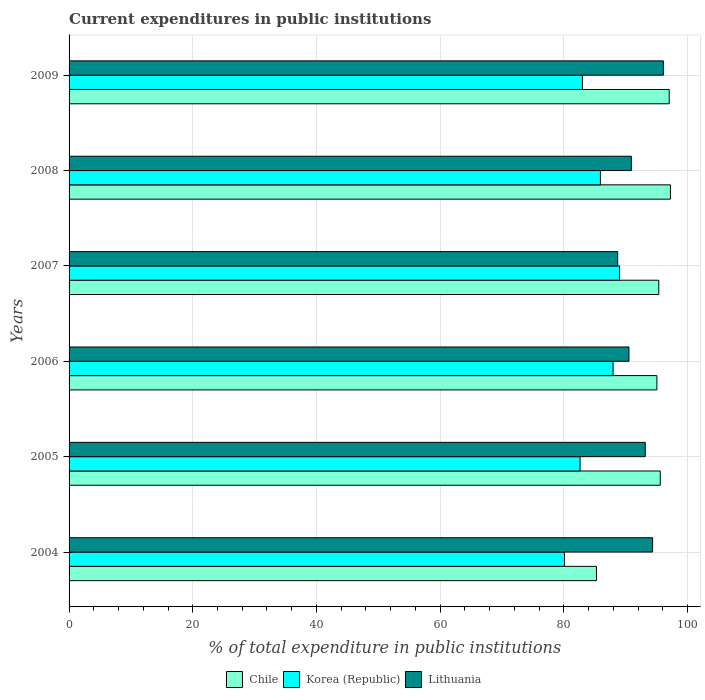How many different coloured bars are there?
Ensure brevity in your answer.  3. Are the number of bars per tick equal to the number of legend labels?
Your answer should be very brief. Yes. How many bars are there on the 2nd tick from the bottom?
Your response must be concise. 3. In how many cases, is the number of bars for a given year not equal to the number of legend labels?
Your answer should be compact. 0. What is the current expenditures in public institutions in Korea (Republic) in 2008?
Keep it short and to the point. 85.91. Across all years, what is the maximum current expenditures in public institutions in Chile?
Offer a very short reply. 97.23. Across all years, what is the minimum current expenditures in public institutions in Korea (Republic)?
Provide a short and direct response. 80.09. In which year was the current expenditures in public institutions in Korea (Republic) maximum?
Provide a succinct answer. 2007. In which year was the current expenditures in public institutions in Chile minimum?
Make the answer very short. 2004. What is the total current expenditures in public institutions in Lithuania in the graph?
Your response must be concise. 553.73. What is the difference between the current expenditures in public institutions in Lithuania in 2006 and that in 2007?
Ensure brevity in your answer.  1.83. What is the difference between the current expenditures in public institutions in Chile in 2009 and the current expenditures in public institutions in Korea (Republic) in 2008?
Your response must be concise. 11.12. What is the average current expenditures in public institutions in Chile per year?
Make the answer very short. 94.25. In the year 2008, what is the difference between the current expenditures in public institutions in Korea (Republic) and current expenditures in public institutions in Lithuania?
Provide a short and direct response. -5. In how many years, is the current expenditures in public institutions in Chile greater than 52 %?
Your response must be concise. 6. What is the ratio of the current expenditures in public institutions in Chile in 2005 to that in 2006?
Your answer should be compact. 1.01. What is the difference between the highest and the second highest current expenditures in public institutions in Chile?
Offer a very short reply. 0.2. What is the difference between the highest and the lowest current expenditures in public institutions in Lithuania?
Offer a very short reply. 7.39. Is the sum of the current expenditures in public institutions in Chile in 2006 and 2008 greater than the maximum current expenditures in public institutions in Lithuania across all years?
Make the answer very short. Yes. What does the 2nd bar from the top in 2007 represents?
Provide a short and direct response. Korea (Republic). What does the 3rd bar from the bottom in 2008 represents?
Offer a terse response. Lithuania. Are all the bars in the graph horizontal?
Offer a very short reply. Yes. How many years are there in the graph?
Make the answer very short. 6. Does the graph contain any zero values?
Keep it short and to the point. No. Where does the legend appear in the graph?
Offer a terse response. Bottom center. What is the title of the graph?
Offer a terse response. Current expenditures in public institutions. Does "Guatemala" appear as one of the legend labels in the graph?
Your response must be concise. No. What is the label or title of the X-axis?
Offer a very short reply. % of total expenditure in public institutions. What is the label or title of the Y-axis?
Your answer should be compact. Years. What is the % of total expenditure in public institutions of Chile in 2004?
Give a very brief answer. 85.27. What is the % of total expenditure in public institutions of Korea (Republic) in 2004?
Ensure brevity in your answer.  80.09. What is the % of total expenditure in public institutions of Lithuania in 2004?
Give a very brief answer. 94.35. What is the % of total expenditure in public institutions in Chile in 2005?
Offer a terse response. 95.59. What is the % of total expenditure in public institutions in Korea (Republic) in 2005?
Make the answer very short. 82.62. What is the % of total expenditure in public institutions in Lithuania in 2005?
Keep it short and to the point. 93.16. What is the % of total expenditure in public institutions in Chile in 2006?
Your answer should be compact. 95.04. What is the % of total expenditure in public institutions of Korea (Republic) in 2006?
Your answer should be very brief. 87.96. What is the % of total expenditure in public institutions in Lithuania in 2006?
Your answer should be compact. 90.53. What is the % of total expenditure in public institutions in Chile in 2007?
Provide a short and direct response. 95.35. What is the % of total expenditure in public institutions in Korea (Republic) in 2007?
Give a very brief answer. 88.99. What is the % of total expenditure in public institutions of Lithuania in 2007?
Ensure brevity in your answer.  88.7. What is the % of total expenditure in public institutions of Chile in 2008?
Offer a terse response. 97.23. What is the % of total expenditure in public institutions in Korea (Republic) in 2008?
Provide a succinct answer. 85.91. What is the % of total expenditure in public institutions in Lithuania in 2008?
Your answer should be very brief. 90.91. What is the % of total expenditure in public institutions of Chile in 2009?
Your answer should be very brief. 97.03. What is the % of total expenditure in public institutions of Korea (Republic) in 2009?
Offer a terse response. 83. What is the % of total expenditure in public institutions in Lithuania in 2009?
Keep it short and to the point. 96.09. Across all years, what is the maximum % of total expenditure in public institutions in Chile?
Offer a very short reply. 97.23. Across all years, what is the maximum % of total expenditure in public institutions of Korea (Republic)?
Give a very brief answer. 88.99. Across all years, what is the maximum % of total expenditure in public institutions of Lithuania?
Give a very brief answer. 96.09. Across all years, what is the minimum % of total expenditure in public institutions in Chile?
Give a very brief answer. 85.27. Across all years, what is the minimum % of total expenditure in public institutions in Korea (Republic)?
Offer a terse response. 80.09. Across all years, what is the minimum % of total expenditure in public institutions in Lithuania?
Keep it short and to the point. 88.7. What is the total % of total expenditure in public institutions of Chile in the graph?
Your response must be concise. 565.51. What is the total % of total expenditure in public institutions in Korea (Republic) in the graph?
Provide a succinct answer. 508.58. What is the total % of total expenditure in public institutions of Lithuania in the graph?
Your answer should be compact. 553.73. What is the difference between the % of total expenditure in public institutions in Chile in 2004 and that in 2005?
Offer a terse response. -10.32. What is the difference between the % of total expenditure in public institutions in Korea (Republic) in 2004 and that in 2005?
Your answer should be very brief. -2.53. What is the difference between the % of total expenditure in public institutions in Lithuania in 2004 and that in 2005?
Your response must be concise. 1.19. What is the difference between the % of total expenditure in public institutions in Chile in 2004 and that in 2006?
Offer a terse response. -9.77. What is the difference between the % of total expenditure in public institutions in Korea (Republic) in 2004 and that in 2006?
Your response must be concise. -7.87. What is the difference between the % of total expenditure in public institutions of Lithuania in 2004 and that in 2006?
Your answer should be very brief. 3.82. What is the difference between the % of total expenditure in public institutions of Chile in 2004 and that in 2007?
Ensure brevity in your answer.  -10.08. What is the difference between the % of total expenditure in public institutions of Korea (Republic) in 2004 and that in 2007?
Your answer should be compact. -8.9. What is the difference between the % of total expenditure in public institutions of Lithuania in 2004 and that in 2007?
Provide a succinct answer. 5.65. What is the difference between the % of total expenditure in public institutions in Chile in 2004 and that in 2008?
Provide a short and direct response. -11.96. What is the difference between the % of total expenditure in public institutions in Korea (Republic) in 2004 and that in 2008?
Your answer should be very brief. -5.82. What is the difference between the % of total expenditure in public institutions in Lithuania in 2004 and that in 2008?
Your answer should be very brief. 3.44. What is the difference between the % of total expenditure in public institutions of Chile in 2004 and that in 2009?
Provide a succinct answer. -11.76. What is the difference between the % of total expenditure in public institutions of Korea (Republic) in 2004 and that in 2009?
Offer a very short reply. -2.91. What is the difference between the % of total expenditure in public institutions in Lithuania in 2004 and that in 2009?
Your response must be concise. -1.74. What is the difference between the % of total expenditure in public institutions in Chile in 2005 and that in 2006?
Provide a short and direct response. 0.55. What is the difference between the % of total expenditure in public institutions in Korea (Republic) in 2005 and that in 2006?
Your answer should be compact. -5.34. What is the difference between the % of total expenditure in public institutions in Lithuania in 2005 and that in 2006?
Provide a succinct answer. 2.63. What is the difference between the % of total expenditure in public institutions in Chile in 2005 and that in 2007?
Your answer should be very brief. 0.24. What is the difference between the % of total expenditure in public institutions of Korea (Republic) in 2005 and that in 2007?
Give a very brief answer. -6.37. What is the difference between the % of total expenditure in public institutions of Lithuania in 2005 and that in 2007?
Give a very brief answer. 4.46. What is the difference between the % of total expenditure in public institutions of Chile in 2005 and that in 2008?
Offer a very short reply. -1.64. What is the difference between the % of total expenditure in public institutions in Korea (Republic) in 2005 and that in 2008?
Keep it short and to the point. -3.29. What is the difference between the % of total expenditure in public institutions of Lithuania in 2005 and that in 2008?
Ensure brevity in your answer.  2.25. What is the difference between the % of total expenditure in public institutions in Chile in 2005 and that in 2009?
Offer a terse response. -1.44. What is the difference between the % of total expenditure in public institutions in Korea (Republic) in 2005 and that in 2009?
Offer a terse response. -0.38. What is the difference between the % of total expenditure in public institutions of Lithuania in 2005 and that in 2009?
Give a very brief answer. -2.93. What is the difference between the % of total expenditure in public institutions of Chile in 2006 and that in 2007?
Offer a terse response. -0.31. What is the difference between the % of total expenditure in public institutions in Korea (Republic) in 2006 and that in 2007?
Make the answer very short. -1.03. What is the difference between the % of total expenditure in public institutions of Lithuania in 2006 and that in 2007?
Your answer should be very brief. 1.83. What is the difference between the % of total expenditure in public institutions of Chile in 2006 and that in 2008?
Provide a short and direct response. -2.19. What is the difference between the % of total expenditure in public institutions in Korea (Republic) in 2006 and that in 2008?
Offer a very short reply. 2.05. What is the difference between the % of total expenditure in public institutions in Lithuania in 2006 and that in 2008?
Make the answer very short. -0.38. What is the difference between the % of total expenditure in public institutions of Chile in 2006 and that in 2009?
Make the answer very short. -1.99. What is the difference between the % of total expenditure in public institutions in Korea (Republic) in 2006 and that in 2009?
Make the answer very short. 4.96. What is the difference between the % of total expenditure in public institutions of Lithuania in 2006 and that in 2009?
Make the answer very short. -5.56. What is the difference between the % of total expenditure in public institutions in Chile in 2007 and that in 2008?
Provide a succinct answer. -1.88. What is the difference between the % of total expenditure in public institutions in Korea (Republic) in 2007 and that in 2008?
Offer a terse response. 3.08. What is the difference between the % of total expenditure in public institutions in Lithuania in 2007 and that in 2008?
Your answer should be compact. -2.21. What is the difference between the % of total expenditure in public institutions in Chile in 2007 and that in 2009?
Offer a terse response. -1.68. What is the difference between the % of total expenditure in public institutions in Korea (Republic) in 2007 and that in 2009?
Your answer should be very brief. 5.99. What is the difference between the % of total expenditure in public institutions of Lithuania in 2007 and that in 2009?
Offer a terse response. -7.39. What is the difference between the % of total expenditure in public institutions in Chile in 2008 and that in 2009?
Provide a short and direct response. 0.2. What is the difference between the % of total expenditure in public institutions of Korea (Republic) in 2008 and that in 2009?
Your response must be concise. 2.91. What is the difference between the % of total expenditure in public institutions of Lithuania in 2008 and that in 2009?
Provide a succinct answer. -5.18. What is the difference between the % of total expenditure in public institutions of Chile in 2004 and the % of total expenditure in public institutions of Korea (Republic) in 2005?
Give a very brief answer. 2.65. What is the difference between the % of total expenditure in public institutions of Chile in 2004 and the % of total expenditure in public institutions of Lithuania in 2005?
Offer a very short reply. -7.88. What is the difference between the % of total expenditure in public institutions in Korea (Republic) in 2004 and the % of total expenditure in public institutions in Lithuania in 2005?
Offer a terse response. -13.06. What is the difference between the % of total expenditure in public institutions of Chile in 2004 and the % of total expenditure in public institutions of Korea (Republic) in 2006?
Keep it short and to the point. -2.69. What is the difference between the % of total expenditure in public institutions in Chile in 2004 and the % of total expenditure in public institutions in Lithuania in 2006?
Provide a succinct answer. -5.25. What is the difference between the % of total expenditure in public institutions of Korea (Republic) in 2004 and the % of total expenditure in public institutions of Lithuania in 2006?
Offer a terse response. -10.43. What is the difference between the % of total expenditure in public institutions in Chile in 2004 and the % of total expenditure in public institutions in Korea (Republic) in 2007?
Make the answer very short. -3.72. What is the difference between the % of total expenditure in public institutions in Chile in 2004 and the % of total expenditure in public institutions in Lithuania in 2007?
Your answer should be very brief. -3.43. What is the difference between the % of total expenditure in public institutions of Korea (Republic) in 2004 and the % of total expenditure in public institutions of Lithuania in 2007?
Make the answer very short. -8.61. What is the difference between the % of total expenditure in public institutions of Chile in 2004 and the % of total expenditure in public institutions of Korea (Republic) in 2008?
Keep it short and to the point. -0.64. What is the difference between the % of total expenditure in public institutions in Chile in 2004 and the % of total expenditure in public institutions in Lithuania in 2008?
Your response must be concise. -5.64. What is the difference between the % of total expenditure in public institutions of Korea (Republic) in 2004 and the % of total expenditure in public institutions of Lithuania in 2008?
Provide a short and direct response. -10.82. What is the difference between the % of total expenditure in public institutions of Chile in 2004 and the % of total expenditure in public institutions of Korea (Republic) in 2009?
Provide a short and direct response. 2.27. What is the difference between the % of total expenditure in public institutions of Chile in 2004 and the % of total expenditure in public institutions of Lithuania in 2009?
Your answer should be compact. -10.82. What is the difference between the % of total expenditure in public institutions in Korea (Republic) in 2004 and the % of total expenditure in public institutions in Lithuania in 2009?
Your answer should be compact. -16. What is the difference between the % of total expenditure in public institutions in Chile in 2005 and the % of total expenditure in public institutions in Korea (Republic) in 2006?
Make the answer very short. 7.63. What is the difference between the % of total expenditure in public institutions of Chile in 2005 and the % of total expenditure in public institutions of Lithuania in 2006?
Offer a very short reply. 5.06. What is the difference between the % of total expenditure in public institutions of Korea (Republic) in 2005 and the % of total expenditure in public institutions of Lithuania in 2006?
Provide a succinct answer. -7.91. What is the difference between the % of total expenditure in public institutions in Chile in 2005 and the % of total expenditure in public institutions in Korea (Republic) in 2007?
Make the answer very short. 6.6. What is the difference between the % of total expenditure in public institutions of Chile in 2005 and the % of total expenditure in public institutions of Lithuania in 2007?
Provide a succinct answer. 6.89. What is the difference between the % of total expenditure in public institutions of Korea (Republic) in 2005 and the % of total expenditure in public institutions of Lithuania in 2007?
Make the answer very short. -6.08. What is the difference between the % of total expenditure in public institutions of Chile in 2005 and the % of total expenditure in public institutions of Korea (Republic) in 2008?
Your answer should be compact. 9.68. What is the difference between the % of total expenditure in public institutions of Chile in 2005 and the % of total expenditure in public institutions of Lithuania in 2008?
Make the answer very short. 4.68. What is the difference between the % of total expenditure in public institutions of Korea (Republic) in 2005 and the % of total expenditure in public institutions of Lithuania in 2008?
Keep it short and to the point. -8.29. What is the difference between the % of total expenditure in public institutions of Chile in 2005 and the % of total expenditure in public institutions of Korea (Republic) in 2009?
Offer a terse response. 12.59. What is the difference between the % of total expenditure in public institutions of Chile in 2005 and the % of total expenditure in public institutions of Lithuania in 2009?
Keep it short and to the point. -0.5. What is the difference between the % of total expenditure in public institutions of Korea (Republic) in 2005 and the % of total expenditure in public institutions of Lithuania in 2009?
Your response must be concise. -13.47. What is the difference between the % of total expenditure in public institutions in Chile in 2006 and the % of total expenditure in public institutions in Korea (Republic) in 2007?
Ensure brevity in your answer.  6.05. What is the difference between the % of total expenditure in public institutions in Chile in 2006 and the % of total expenditure in public institutions in Lithuania in 2007?
Provide a short and direct response. 6.34. What is the difference between the % of total expenditure in public institutions of Korea (Republic) in 2006 and the % of total expenditure in public institutions of Lithuania in 2007?
Provide a succinct answer. -0.74. What is the difference between the % of total expenditure in public institutions of Chile in 2006 and the % of total expenditure in public institutions of Korea (Republic) in 2008?
Your answer should be very brief. 9.13. What is the difference between the % of total expenditure in public institutions of Chile in 2006 and the % of total expenditure in public institutions of Lithuania in 2008?
Provide a short and direct response. 4.13. What is the difference between the % of total expenditure in public institutions of Korea (Republic) in 2006 and the % of total expenditure in public institutions of Lithuania in 2008?
Make the answer very short. -2.95. What is the difference between the % of total expenditure in public institutions of Chile in 2006 and the % of total expenditure in public institutions of Korea (Republic) in 2009?
Your answer should be very brief. 12.04. What is the difference between the % of total expenditure in public institutions of Chile in 2006 and the % of total expenditure in public institutions of Lithuania in 2009?
Give a very brief answer. -1.05. What is the difference between the % of total expenditure in public institutions of Korea (Republic) in 2006 and the % of total expenditure in public institutions of Lithuania in 2009?
Ensure brevity in your answer.  -8.13. What is the difference between the % of total expenditure in public institutions in Chile in 2007 and the % of total expenditure in public institutions in Korea (Republic) in 2008?
Offer a very short reply. 9.44. What is the difference between the % of total expenditure in public institutions of Chile in 2007 and the % of total expenditure in public institutions of Lithuania in 2008?
Ensure brevity in your answer.  4.44. What is the difference between the % of total expenditure in public institutions in Korea (Republic) in 2007 and the % of total expenditure in public institutions in Lithuania in 2008?
Ensure brevity in your answer.  -1.92. What is the difference between the % of total expenditure in public institutions in Chile in 2007 and the % of total expenditure in public institutions in Korea (Republic) in 2009?
Provide a succinct answer. 12.35. What is the difference between the % of total expenditure in public institutions of Chile in 2007 and the % of total expenditure in public institutions of Lithuania in 2009?
Offer a terse response. -0.74. What is the difference between the % of total expenditure in public institutions in Korea (Republic) in 2007 and the % of total expenditure in public institutions in Lithuania in 2009?
Ensure brevity in your answer.  -7.1. What is the difference between the % of total expenditure in public institutions of Chile in 2008 and the % of total expenditure in public institutions of Korea (Republic) in 2009?
Your response must be concise. 14.23. What is the difference between the % of total expenditure in public institutions in Chile in 2008 and the % of total expenditure in public institutions in Lithuania in 2009?
Your answer should be compact. 1.14. What is the difference between the % of total expenditure in public institutions of Korea (Republic) in 2008 and the % of total expenditure in public institutions of Lithuania in 2009?
Offer a terse response. -10.18. What is the average % of total expenditure in public institutions of Chile per year?
Offer a terse response. 94.25. What is the average % of total expenditure in public institutions of Korea (Republic) per year?
Give a very brief answer. 84.76. What is the average % of total expenditure in public institutions in Lithuania per year?
Your answer should be compact. 92.29. In the year 2004, what is the difference between the % of total expenditure in public institutions of Chile and % of total expenditure in public institutions of Korea (Republic)?
Provide a short and direct response. 5.18. In the year 2004, what is the difference between the % of total expenditure in public institutions in Chile and % of total expenditure in public institutions in Lithuania?
Provide a short and direct response. -9.08. In the year 2004, what is the difference between the % of total expenditure in public institutions of Korea (Republic) and % of total expenditure in public institutions of Lithuania?
Your answer should be very brief. -14.26. In the year 2005, what is the difference between the % of total expenditure in public institutions of Chile and % of total expenditure in public institutions of Korea (Republic)?
Make the answer very short. 12.97. In the year 2005, what is the difference between the % of total expenditure in public institutions of Chile and % of total expenditure in public institutions of Lithuania?
Provide a succinct answer. 2.43. In the year 2005, what is the difference between the % of total expenditure in public institutions of Korea (Republic) and % of total expenditure in public institutions of Lithuania?
Ensure brevity in your answer.  -10.53. In the year 2006, what is the difference between the % of total expenditure in public institutions in Chile and % of total expenditure in public institutions in Korea (Republic)?
Keep it short and to the point. 7.08. In the year 2006, what is the difference between the % of total expenditure in public institutions of Chile and % of total expenditure in public institutions of Lithuania?
Keep it short and to the point. 4.51. In the year 2006, what is the difference between the % of total expenditure in public institutions in Korea (Republic) and % of total expenditure in public institutions in Lithuania?
Offer a very short reply. -2.57. In the year 2007, what is the difference between the % of total expenditure in public institutions of Chile and % of total expenditure in public institutions of Korea (Republic)?
Give a very brief answer. 6.36. In the year 2007, what is the difference between the % of total expenditure in public institutions of Chile and % of total expenditure in public institutions of Lithuania?
Your response must be concise. 6.65. In the year 2007, what is the difference between the % of total expenditure in public institutions in Korea (Republic) and % of total expenditure in public institutions in Lithuania?
Your answer should be very brief. 0.29. In the year 2008, what is the difference between the % of total expenditure in public institutions in Chile and % of total expenditure in public institutions in Korea (Republic)?
Offer a terse response. 11.32. In the year 2008, what is the difference between the % of total expenditure in public institutions in Chile and % of total expenditure in public institutions in Lithuania?
Give a very brief answer. 6.32. In the year 2008, what is the difference between the % of total expenditure in public institutions in Korea (Republic) and % of total expenditure in public institutions in Lithuania?
Give a very brief answer. -5. In the year 2009, what is the difference between the % of total expenditure in public institutions of Chile and % of total expenditure in public institutions of Korea (Republic)?
Ensure brevity in your answer.  14.03. In the year 2009, what is the difference between the % of total expenditure in public institutions in Chile and % of total expenditure in public institutions in Lithuania?
Offer a very short reply. 0.94. In the year 2009, what is the difference between the % of total expenditure in public institutions of Korea (Republic) and % of total expenditure in public institutions of Lithuania?
Keep it short and to the point. -13.09. What is the ratio of the % of total expenditure in public institutions in Chile in 2004 to that in 2005?
Keep it short and to the point. 0.89. What is the ratio of the % of total expenditure in public institutions in Korea (Republic) in 2004 to that in 2005?
Give a very brief answer. 0.97. What is the ratio of the % of total expenditure in public institutions in Lithuania in 2004 to that in 2005?
Provide a short and direct response. 1.01. What is the ratio of the % of total expenditure in public institutions in Chile in 2004 to that in 2006?
Offer a terse response. 0.9. What is the ratio of the % of total expenditure in public institutions in Korea (Republic) in 2004 to that in 2006?
Your answer should be very brief. 0.91. What is the ratio of the % of total expenditure in public institutions of Lithuania in 2004 to that in 2006?
Provide a succinct answer. 1.04. What is the ratio of the % of total expenditure in public institutions in Chile in 2004 to that in 2007?
Give a very brief answer. 0.89. What is the ratio of the % of total expenditure in public institutions of Lithuania in 2004 to that in 2007?
Your answer should be compact. 1.06. What is the ratio of the % of total expenditure in public institutions in Chile in 2004 to that in 2008?
Your answer should be compact. 0.88. What is the ratio of the % of total expenditure in public institutions of Korea (Republic) in 2004 to that in 2008?
Your response must be concise. 0.93. What is the ratio of the % of total expenditure in public institutions in Lithuania in 2004 to that in 2008?
Your answer should be compact. 1.04. What is the ratio of the % of total expenditure in public institutions in Chile in 2004 to that in 2009?
Make the answer very short. 0.88. What is the ratio of the % of total expenditure in public institutions in Korea (Republic) in 2004 to that in 2009?
Offer a very short reply. 0.96. What is the ratio of the % of total expenditure in public institutions in Lithuania in 2004 to that in 2009?
Give a very brief answer. 0.98. What is the ratio of the % of total expenditure in public institutions of Korea (Republic) in 2005 to that in 2006?
Provide a succinct answer. 0.94. What is the ratio of the % of total expenditure in public institutions in Lithuania in 2005 to that in 2006?
Your response must be concise. 1.03. What is the ratio of the % of total expenditure in public institutions of Korea (Republic) in 2005 to that in 2007?
Provide a short and direct response. 0.93. What is the ratio of the % of total expenditure in public institutions in Lithuania in 2005 to that in 2007?
Your answer should be compact. 1.05. What is the ratio of the % of total expenditure in public institutions of Chile in 2005 to that in 2008?
Offer a terse response. 0.98. What is the ratio of the % of total expenditure in public institutions of Korea (Republic) in 2005 to that in 2008?
Offer a terse response. 0.96. What is the ratio of the % of total expenditure in public institutions in Lithuania in 2005 to that in 2008?
Ensure brevity in your answer.  1.02. What is the ratio of the % of total expenditure in public institutions of Chile in 2005 to that in 2009?
Your answer should be compact. 0.99. What is the ratio of the % of total expenditure in public institutions in Lithuania in 2005 to that in 2009?
Your answer should be compact. 0.97. What is the ratio of the % of total expenditure in public institutions of Chile in 2006 to that in 2007?
Offer a terse response. 1. What is the ratio of the % of total expenditure in public institutions in Korea (Republic) in 2006 to that in 2007?
Your answer should be compact. 0.99. What is the ratio of the % of total expenditure in public institutions in Lithuania in 2006 to that in 2007?
Offer a very short reply. 1.02. What is the ratio of the % of total expenditure in public institutions of Chile in 2006 to that in 2008?
Provide a succinct answer. 0.98. What is the ratio of the % of total expenditure in public institutions of Korea (Republic) in 2006 to that in 2008?
Your answer should be compact. 1.02. What is the ratio of the % of total expenditure in public institutions in Chile in 2006 to that in 2009?
Give a very brief answer. 0.98. What is the ratio of the % of total expenditure in public institutions in Korea (Republic) in 2006 to that in 2009?
Make the answer very short. 1.06. What is the ratio of the % of total expenditure in public institutions in Lithuania in 2006 to that in 2009?
Ensure brevity in your answer.  0.94. What is the ratio of the % of total expenditure in public institutions in Chile in 2007 to that in 2008?
Your answer should be compact. 0.98. What is the ratio of the % of total expenditure in public institutions in Korea (Republic) in 2007 to that in 2008?
Provide a succinct answer. 1.04. What is the ratio of the % of total expenditure in public institutions of Lithuania in 2007 to that in 2008?
Provide a succinct answer. 0.98. What is the ratio of the % of total expenditure in public institutions in Chile in 2007 to that in 2009?
Your answer should be very brief. 0.98. What is the ratio of the % of total expenditure in public institutions in Korea (Republic) in 2007 to that in 2009?
Your answer should be compact. 1.07. What is the ratio of the % of total expenditure in public institutions in Korea (Republic) in 2008 to that in 2009?
Keep it short and to the point. 1.03. What is the ratio of the % of total expenditure in public institutions of Lithuania in 2008 to that in 2009?
Provide a succinct answer. 0.95. What is the difference between the highest and the second highest % of total expenditure in public institutions in Chile?
Your answer should be very brief. 0.2. What is the difference between the highest and the second highest % of total expenditure in public institutions in Korea (Republic)?
Ensure brevity in your answer.  1.03. What is the difference between the highest and the second highest % of total expenditure in public institutions of Lithuania?
Your answer should be compact. 1.74. What is the difference between the highest and the lowest % of total expenditure in public institutions of Chile?
Offer a very short reply. 11.96. What is the difference between the highest and the lowest % of total expenditure in public institutions in Korea (Republic)?
Provide a succinct answer. 8.9. What is the difference between the highest and the lowest % of total expenditure in public institutions in Lithuania?
Give a very brief answer. 7.39. 